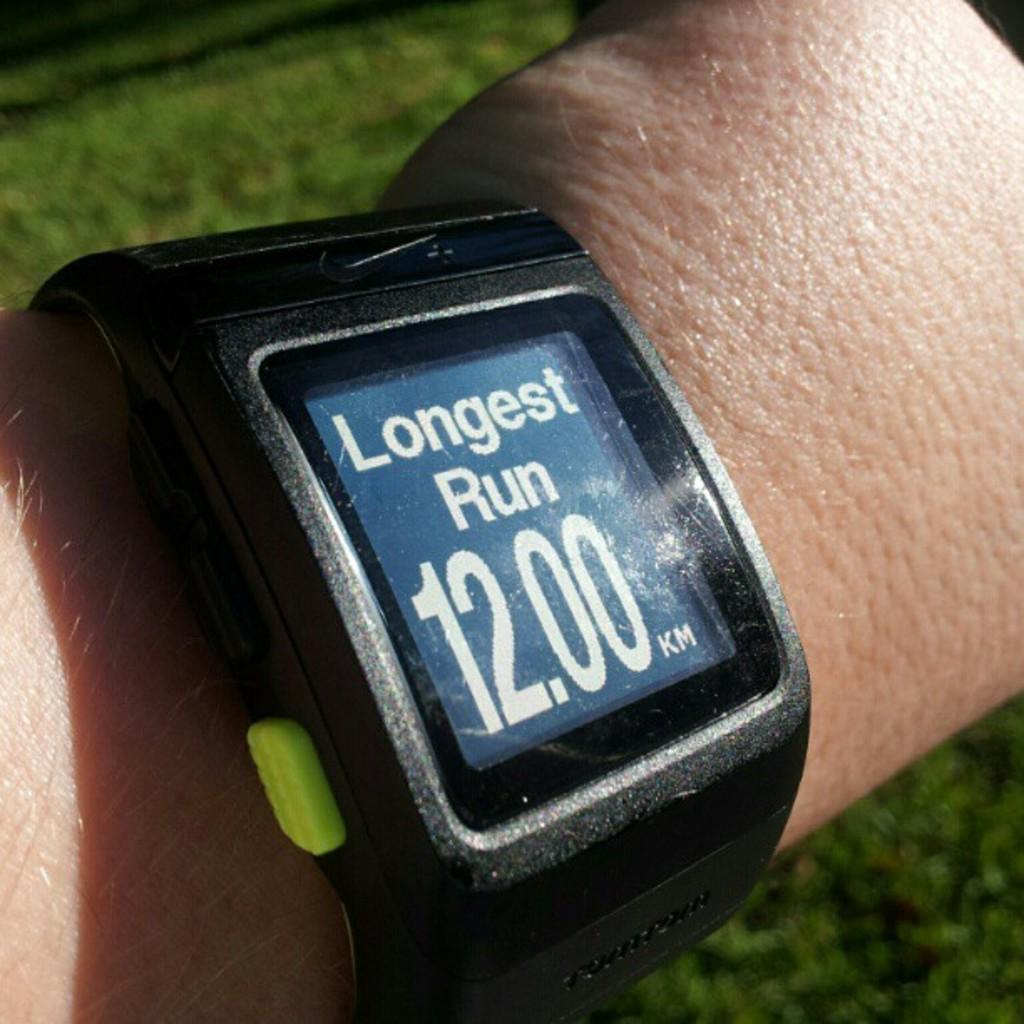How long was the run?
Provide a short and direct response. 12.00 km. 12 km length run?
Provide a short and direct response. Yes. 